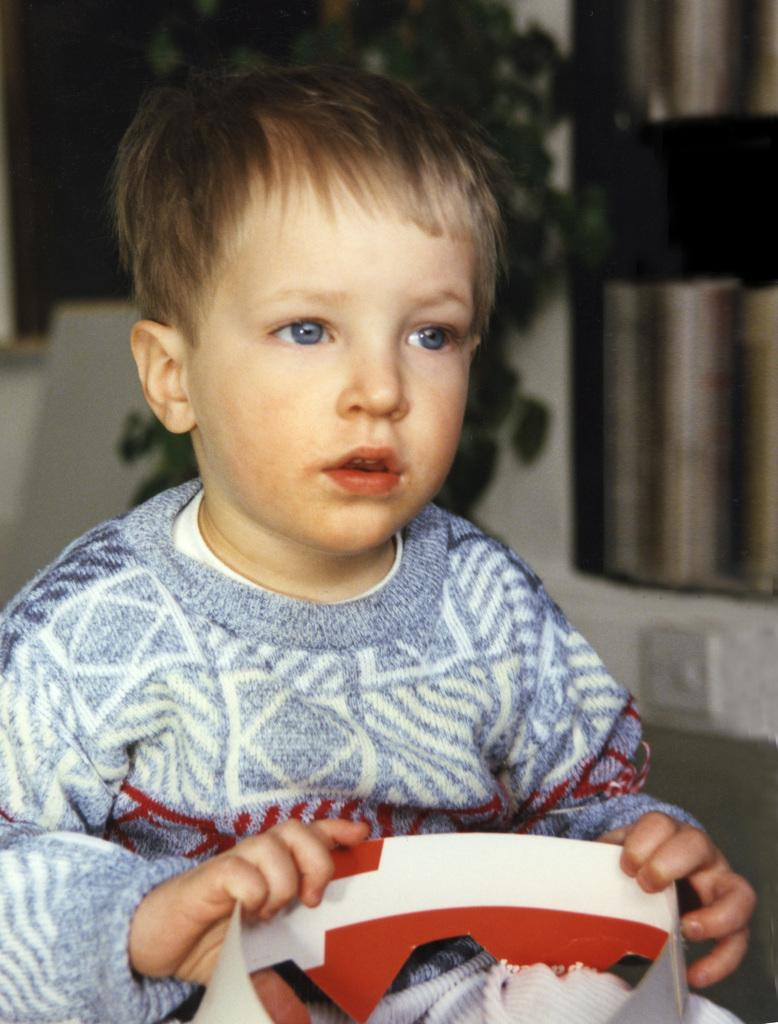What is the main subject of the image? The main subject of the image is a boy. What is the boy holding in his hands? The boy is holding a paper bag in his hands. What type of creature can be seen crawling down the boy's throat in the image? There is no creature visible in the image, let alone crawling down the boy's throat. 